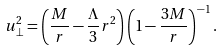Convert formula to latex. <formula><loc_0><loc_0><loc_500><loc_500>u _ { \perp } ^ { 2 } = \left ( \frac { M } { r } - \frac { \Lambda } { 3 } r ^ { 2 } \right ) \left ( 1 - \frac { 3 M } { r } \right ) ^ { - 1 } .</formula> 